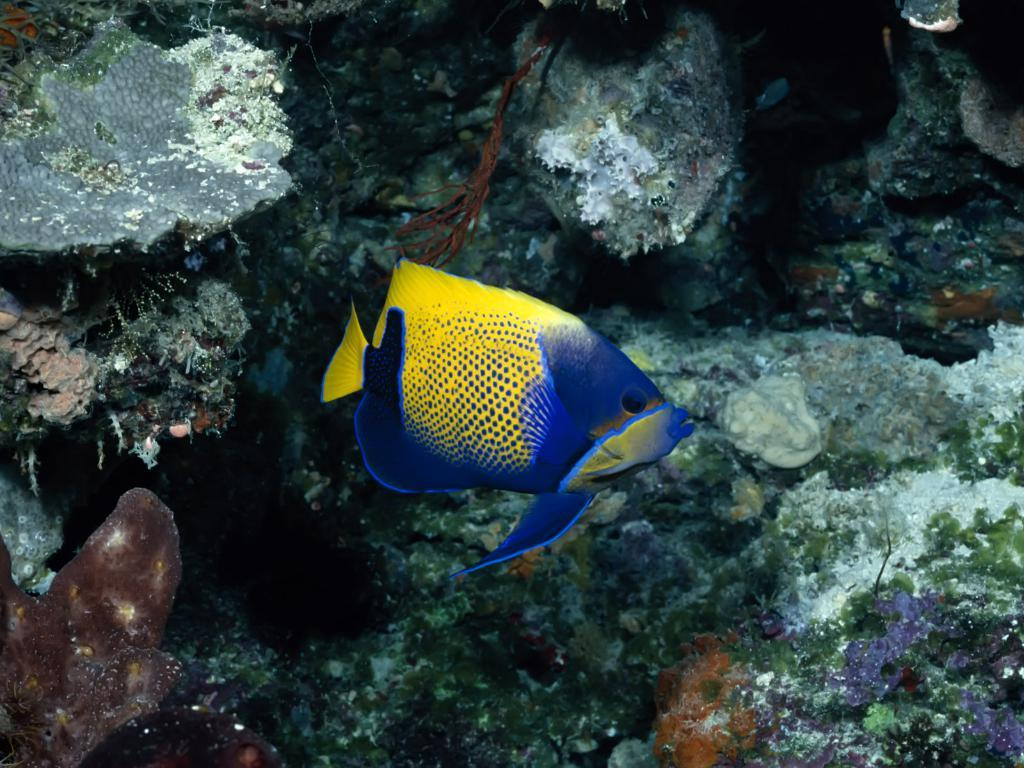What type of animal can be seen in the image? There is a fish in the image. What other objects or features are present in the image? There are corals in the image. Where are the fish and corals located? The fish and corals are underwater. What type of bait is being used to catch the fish in the image? There is no bait present in the image, as it is a natural underwater scene with a fish and corals. 